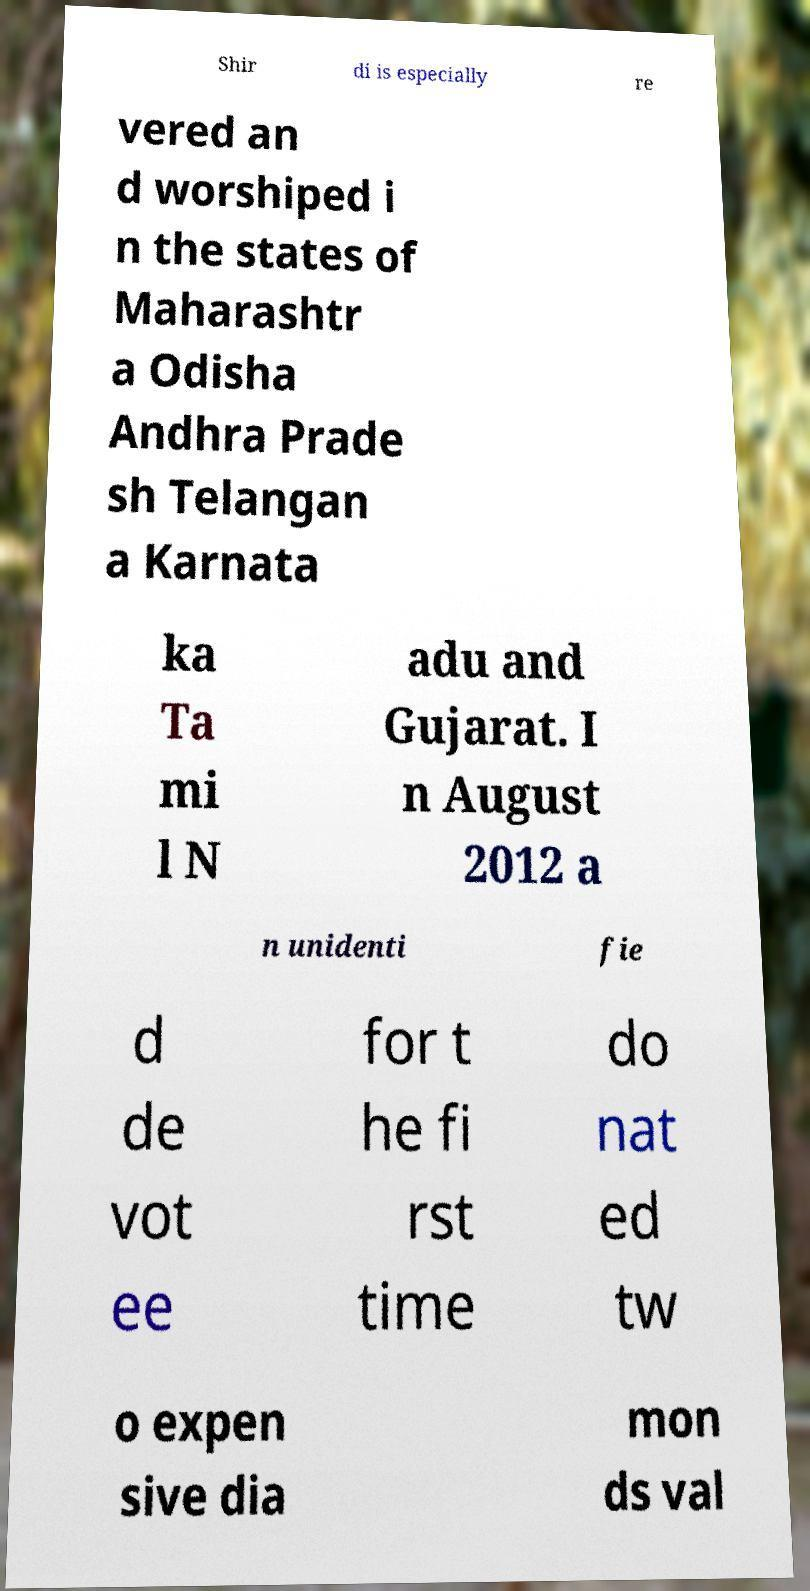Please read and relay the text visible in this image. What does it say? Shir di is especially re vered an d worshiped i n the states of Maharashtr a Odisha Andhra Prade sh Telangan a Karnata ka Ta mi l N adu and Gujarat. I n August 2012 a n unidenti fie d de vot ee for t he fi rst time do nat ed tw o expen sive dia mon ds val 